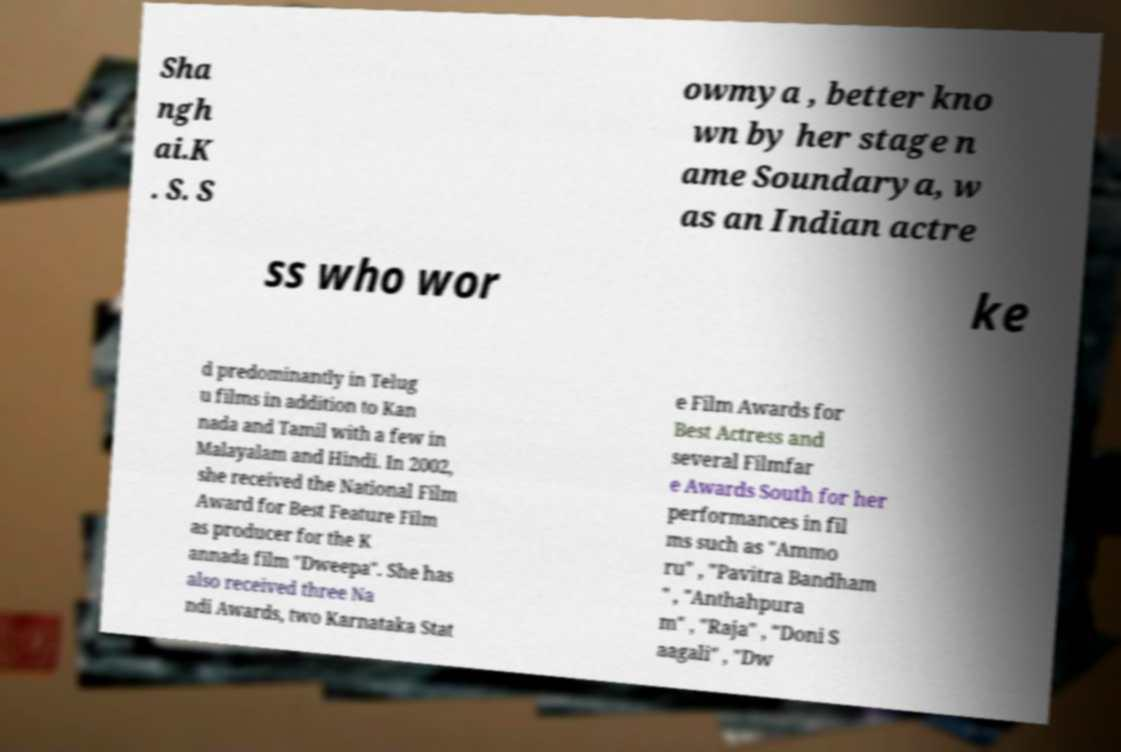What messages or text are displayed in this image? I need them in a readable, typed format. Sha ngh ai.K . S. S owmya , better kno wn by her stage n ame Soundarya, w as an Indian actre ss who wor ke d predominantly in Telug u films in addition to Kan nada and Tamil with a few in Malayalam and Hindi. In 2002, she received the National Film Award for Best Feature Film as producer for the K annada film "Dweepa". She has also received three Na ndi Awards, two Karnataka Stat e Film Awards for Best Actress and several Filmfar e Awards South for her performances in fil ms such as "Ammo ru" , "Pavitra Bandham " , "Anthahpura m" , "Raja" , "Doni S aagali" , "Dw 